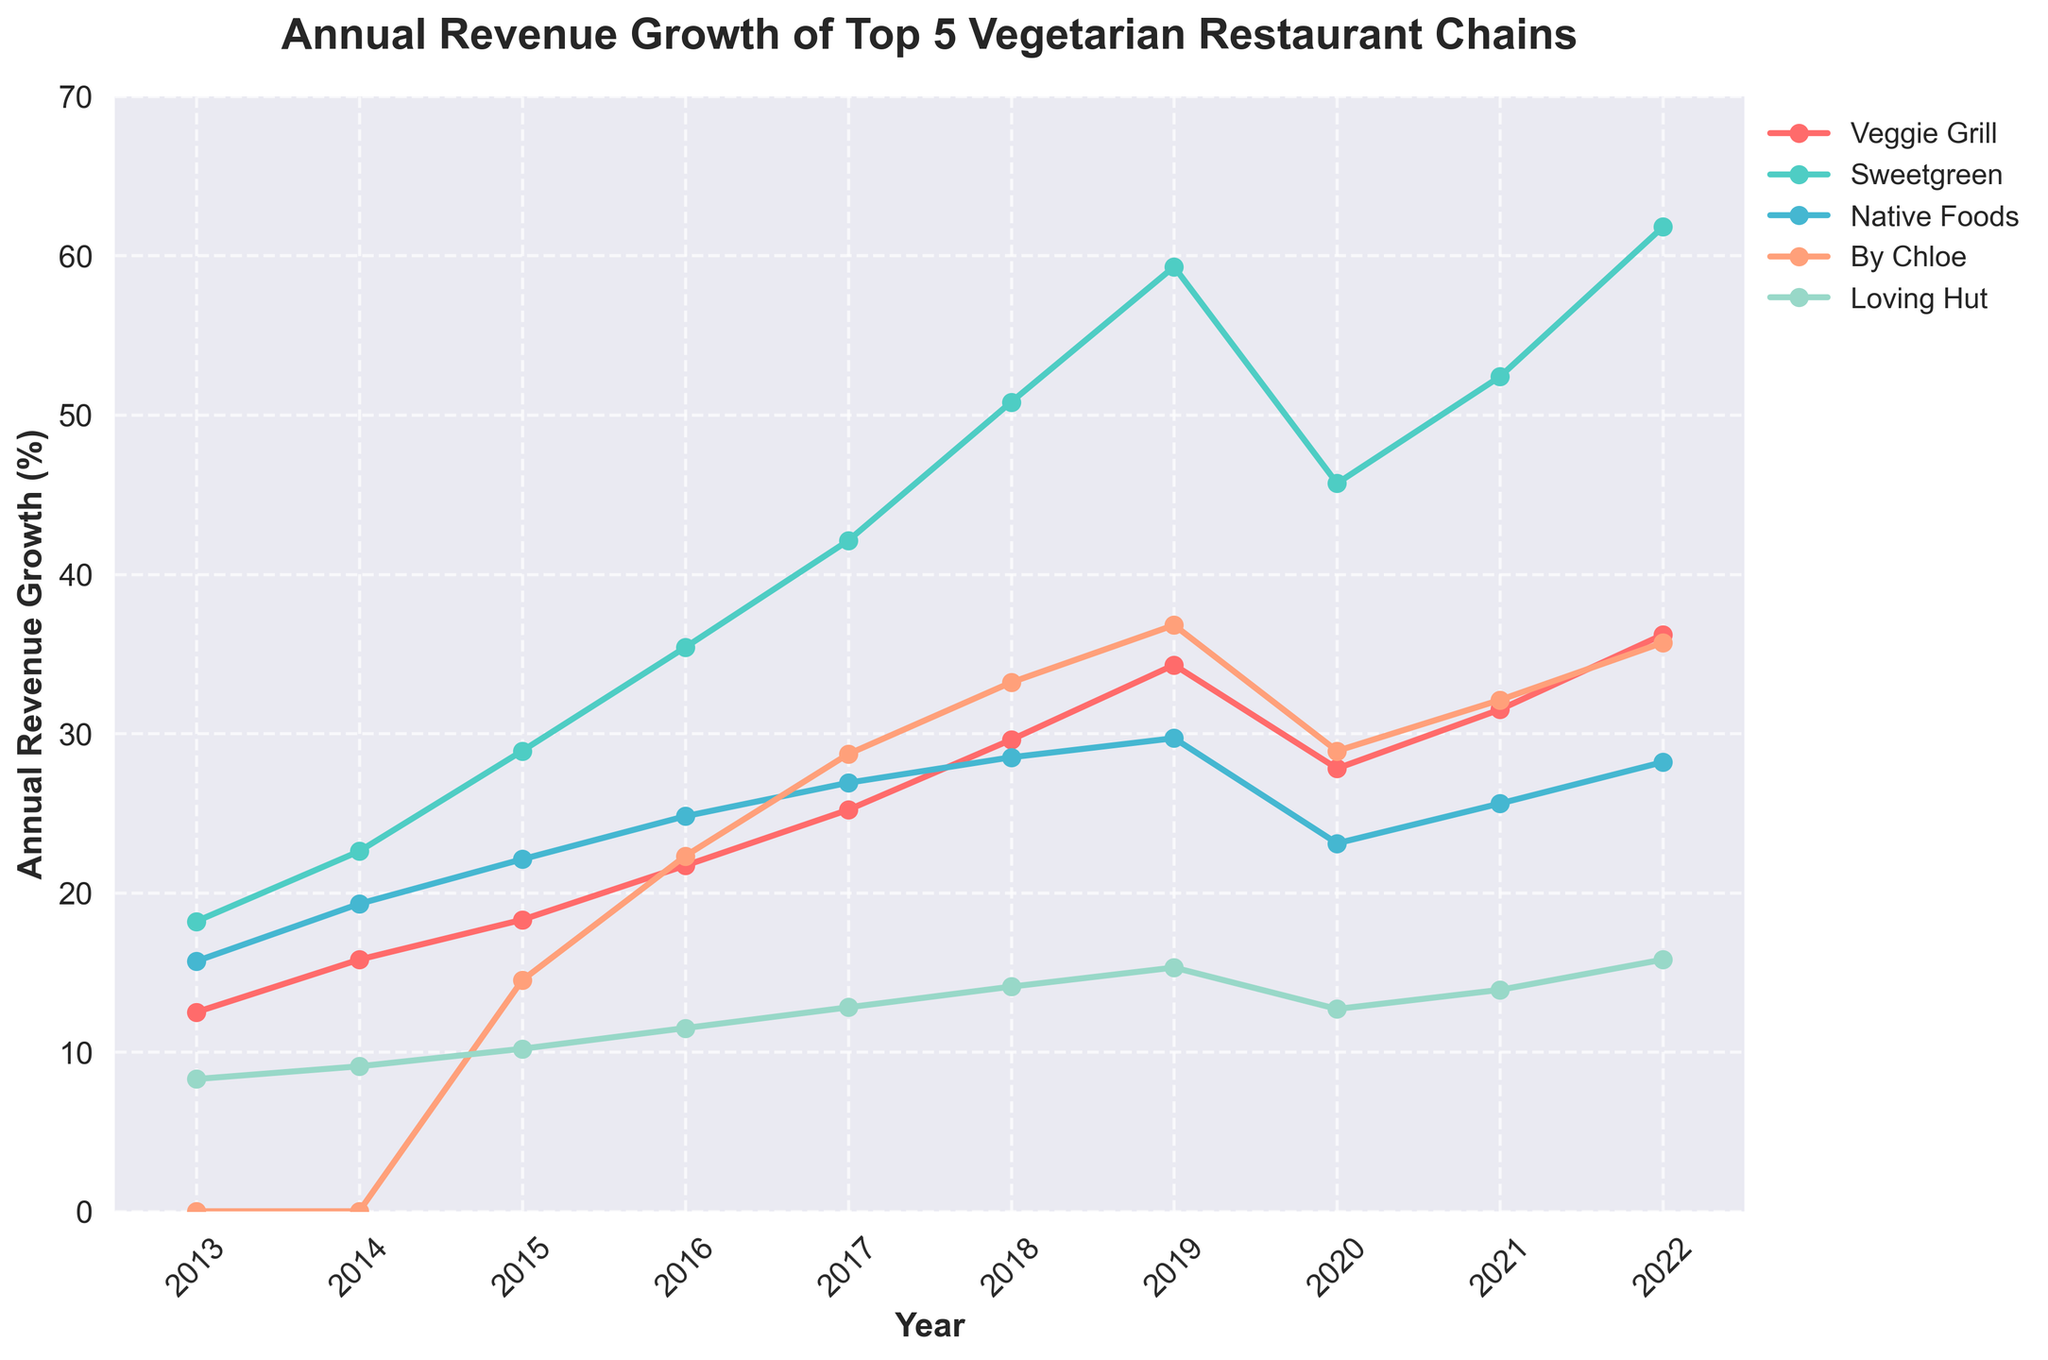Which restaurant had the highest annual revenue growth in 2018? In the figure, find the highest point on the y-axis for the year 2018. The highest point is from the "Sweetgreen" line.
Answer: Sweetgreen Comparing 2020 and 2021, which restaurant showed the greatest percentage increase in annual revenue growth? In 2020, "Sweetgreen" had 45.7%, and in 2021, it had 52.4%. The difference is 52.4% - 45.7% = 6.7%. Compared to other restaurants, "Sweetgreen" has the highest increase.
Answer: Sweetgreen In which year did "By Chloe" experience the largest increase in annual revenue growth compared to the previous year? Calculate the yearly increase for "By Chloe": from 2015 to 2016 (22.3 - 14.5 = 7.8), 2016 to 2017 (28.7 - 22.3 = 6.4), 2017 to 2018 (33.2 - 28.7 = 4.5), and so forth. The largest increase is from 2015 to 2016 with 7.8%.
Answer: 2016 How did the revenue growth of "Veggie Grill" change between 2013 and 2022? Look at the data points for "Veggie Grill" in 2013 (12.5%) and 2022 (36.2%) and subtract the 2013 value from the 2022 value: 36.2% - 12.5% = 23.7%.
Answer: Increased by 23.7% Which restaurant had the least revenue growth in 2020? Examine the 2020 data points and find the smallest value. "Native Foods" had the smallest annual revenue growth of 23.1%.
Answer: Native Foods On average, how much did "Loving Hut" grow per year from 2013 to 2022? To find the average annual growth, sum the yearly growth percentages for "Loving Hut" (8.3 + 9.1 + 10.2 + 11.5 + 12.8 + 14.1 + 15.3 + 12.7 + 13.9 + 15.8 = 123.7) and divide by the number of years (10): 123.7 / 10 ≈ 12.37%.
Answer: 12.37% By how much did "Sweetgreen" outperform "Veggie Grill" in 2022? In 2022, "Sweetgreen" had a growth of 61.8%, and "Veggie Grill" had 36.2%. Subtract the "Veggie Grill" value from the "Sweetgreen" value: 61.8% - 36.2% = 25.6%.
Answer: 25.6% Which restaurant saw a decrease in annual growth from 2019 to 2020? Look at the data points from 2019 to 2020 for each restaurant. Both "Veggie Grill" (34.3 to 27.8) and "Sweetgreen" (59.3 to 45.7) show decreases.
Answer: Veggie Grill, Sweetgreen In what year did "Native Foods" hit its peak revenue growth, and what was the value? Find the highest point on the line for "Native Foods". The highest value is in 2017 at 26.9%.
Answer: 2017, 26.9% 